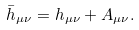Convert formula to latex. <formula><loc_0><loc_0><loc_500><loc_500>\bar { h } _ { \mu \nu } = h _ { \mu \nu } + A _ { \mu \nu } .</formula> 